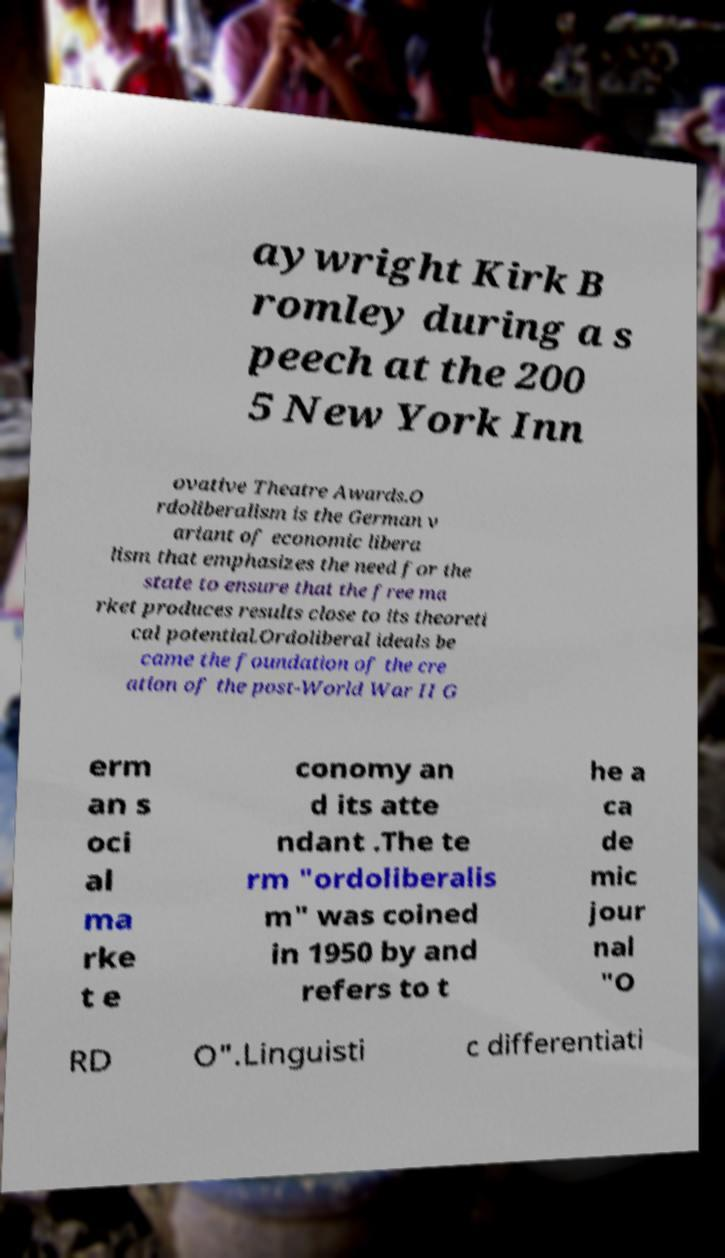I need the written content from this picture converted into text. Can you do that? aywright Kirk B romley during a s peech at the 200 5 New York Inn ovative Theatre Awards.O rdoliberalism is the German v ariant of economic libera lism that emphasizes the need for the state to ensure that the free ma rket produces results close to its theoreti cal potential.Ordoliberal ideals be came the foundation of the cre ation of the post-World War II G erm an s oci al ma rke t e conomy an d its atte ndant .The te rm "ordoliberalis m" was coined in 1950 by and refers to t he a ca de mic jour nal "O RD O".Linguisti c differentiati 